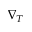Convert formula to latex. <formula><loc_0><loc_0><loc_500><loc_500>\nabla _ { T }</formula> 